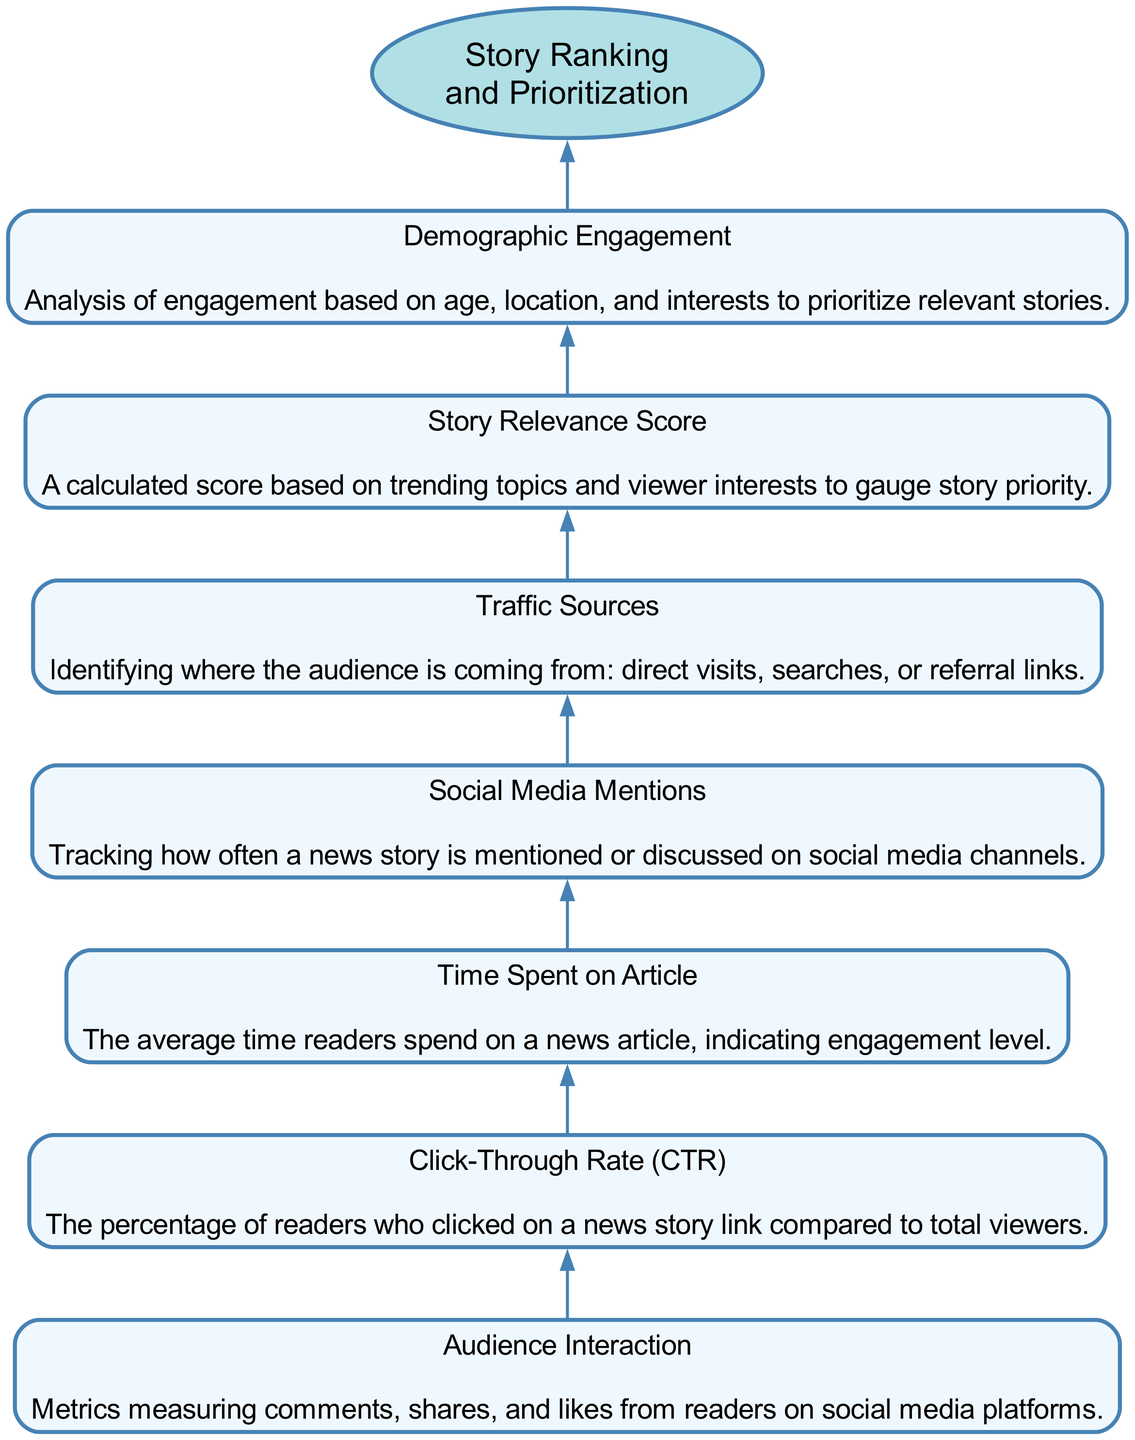What is the top-level node in the diagram? The top-level node is labeled "Story Ranking and Prioritization." It serves as the main focus of the flow chart, summarizing the overall theme or purpose of the diagram.
Answer: Story Ranking and Prioritization How many total elements are in the diagram? The diagram includes seven elements related to audience engagement metrics that contribute to story ranking. By counting each described element, we find the total.
Answer: Seven Which element comes immediately before "Story Relevance Score"? "Traffic Sources" is the element that is listed just before "Story Relevance Score" in the sequence of the diagram. By examining the flow from the bottom to the top, we can determine this order.
Answer: Traffic Sources What does "Audience Interaction" measure? "Audience Interaction" measures metrics including comments, shares, and likes from readers on social media platforms. This is described within the node representing this element.
Answer: Comments, shares, and likes Which node has a description that mentions analysis based on age and location? "Demographic Engagement" is the node that includes analysis based on age, location, and interests to prioritize relevant stories. This can be easily identified through its description.
Answer: Demographic Engagement What is the relationship between "Time Spent on Article" and "Click-Through Rate"? Both "Time Spent on Article" and "Click-Through Rate" are part of the flow that contributes to the overall audience engagement metrics, leading up to the top-level node. They are sequentially connected, indicating that both are important in assessing story ranking.
Answer: Contributing elements What element indicates how often a story is discussed on social media? "Social Media Mentions" indicates how often a news story is mentioned or discussed across various social media platforms. This element is explicitly defined in the diagram.
Answer: Social Media Mentions Which two nodes are most directly related to direct audience interaction feedback? "Audience Interaction" and "Social Media Mentions" are the two nodes that directly gather feedback from readers regarding their engagement with news stories on social media and other platforms. These connections show their interaction with audience metrics.
Answer: Audience Interaction and Social Media Mentions What metric tracks the source of audience traffic? "Traffic Sources" is the metric that identifies where the audience is coming from, whether through direct visits, searches, or referral links, highlighting its role in audience analysis.
Answer: Traffic Sources 